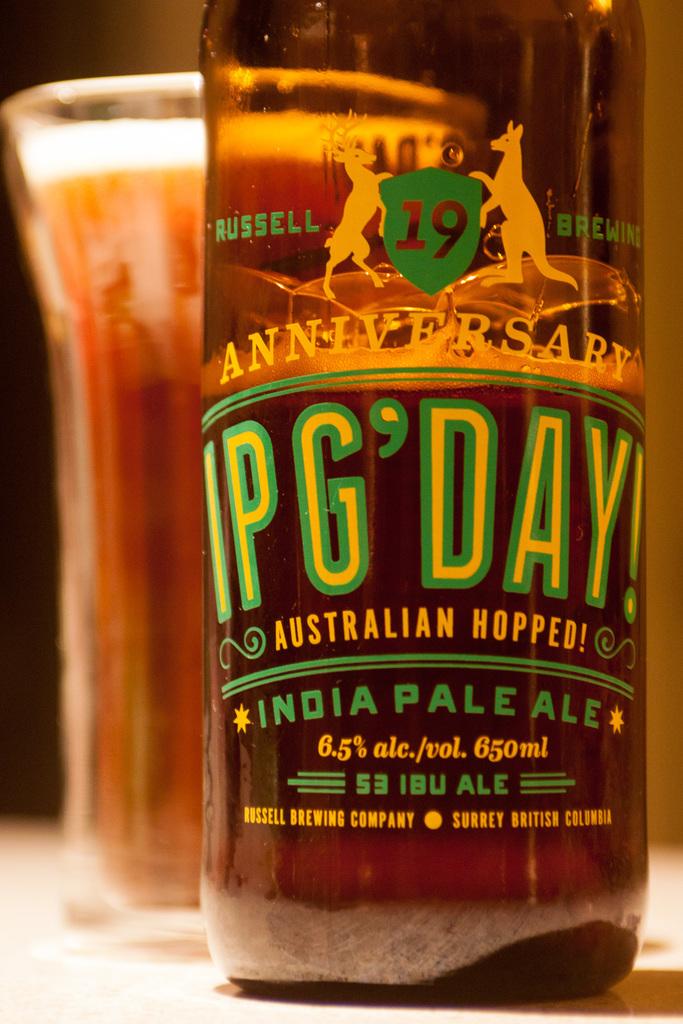Where is this pale ale made?
Keep it short and to the point. India. Which company made the beer?
Ensure brevity in your answer.  Russell brewing. 